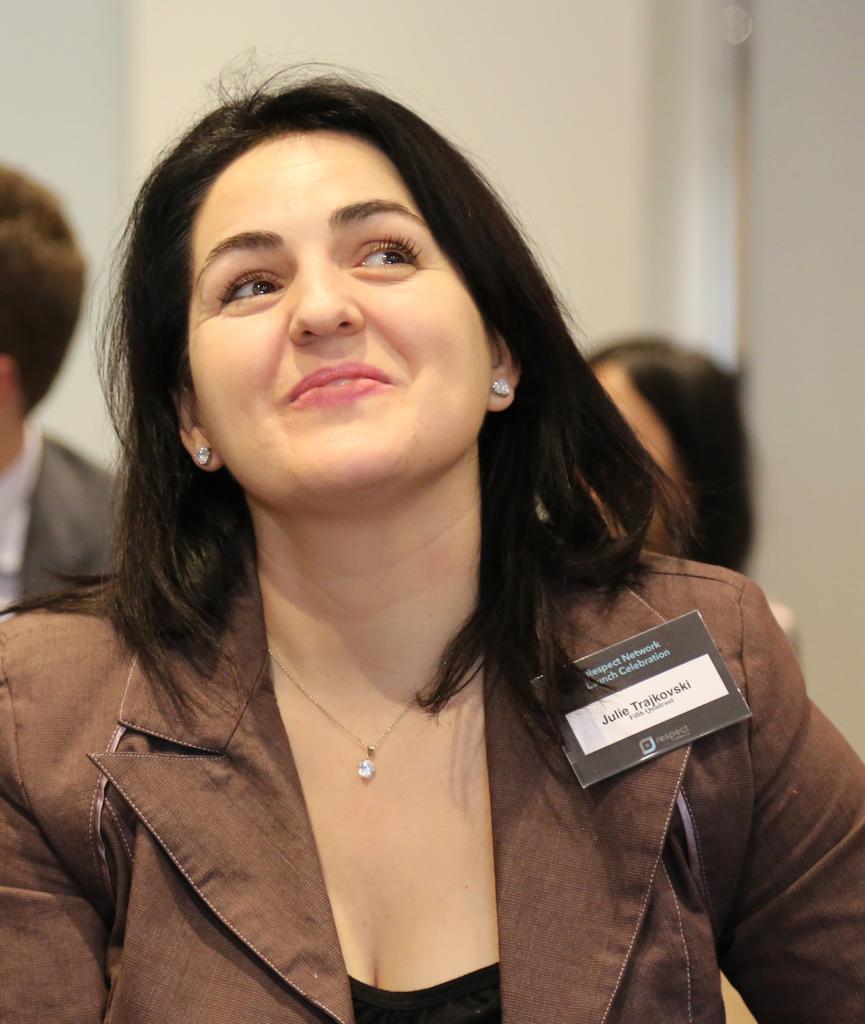Please provide a concise description of this image. In this image there is a woman with a smile on her face, the woman is wearing a name batch on her sleeves. 